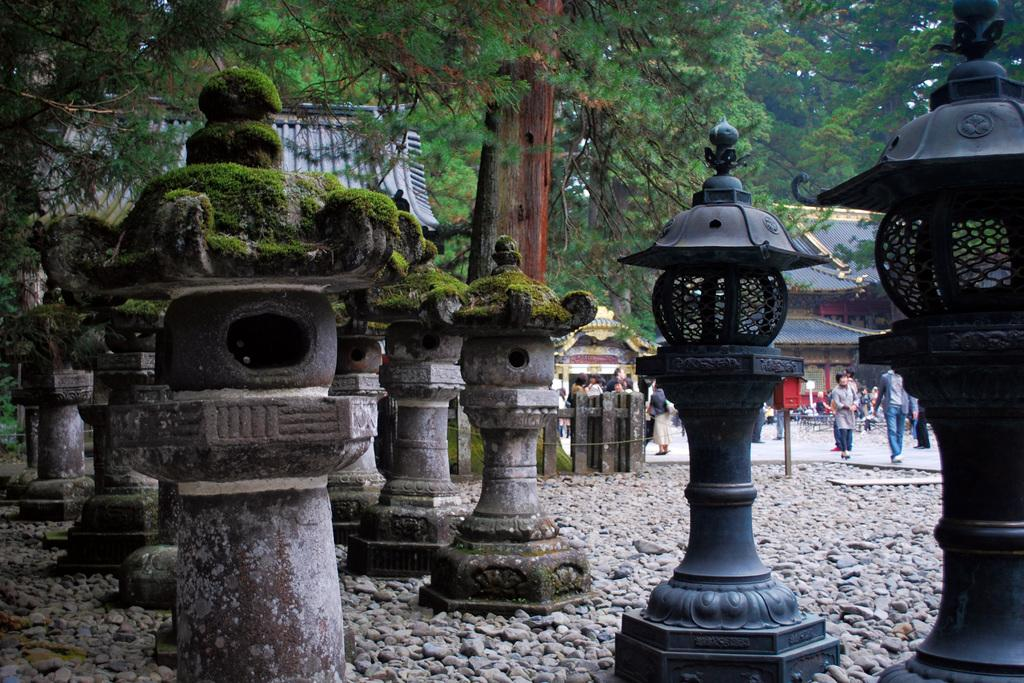What objects are on the stones in the image? There are poles on the stones in the image. What can be seen behind the poles? There are trees, buildings, and people behind the poles. What type of barrier is present behind the poles? There is a wooden fence behind the poles. What is the purpose of the bells in the image? There are no bells present in the image. 